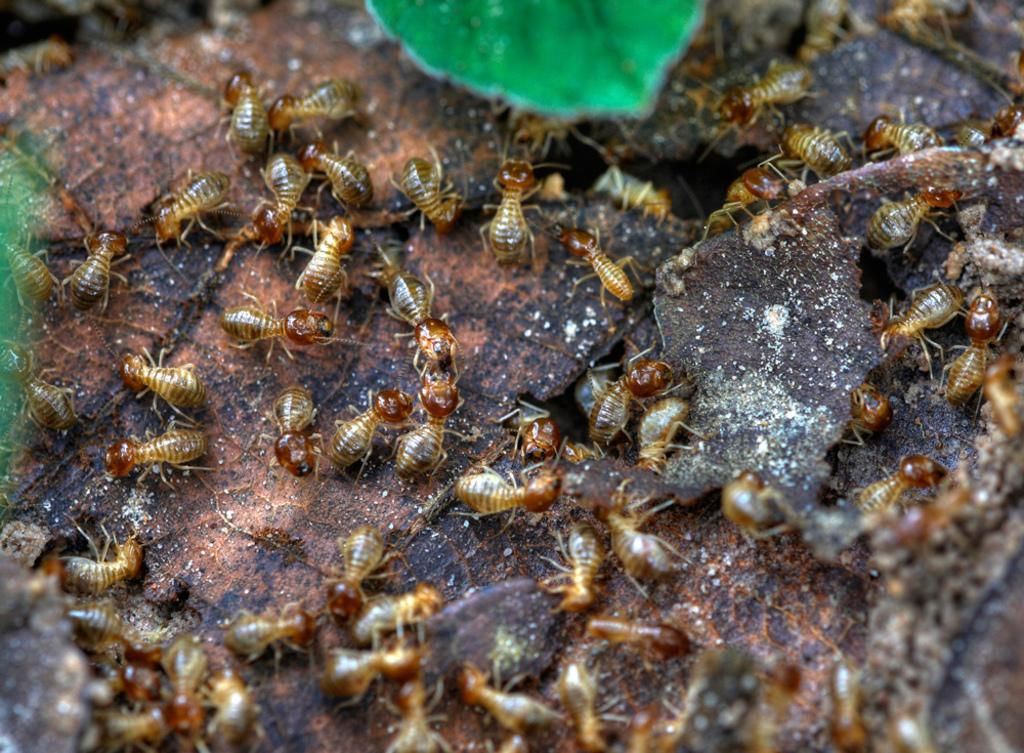What type of insects can be seen in the image? There are multiple ants in the image. What might the ants be attracted to in the image? The ants might be attracted to the sugar in the image. What type of vegetation is present in the image? There is a plant in the image. What type of object can be seen in the image that is not organic? There is a stone in the image. What type of shirt is the ant wearing in the image? There are no ants wearing shirts in the image. Can you read any writing on the stone in the image? There is no writing present on the stone in the image. 